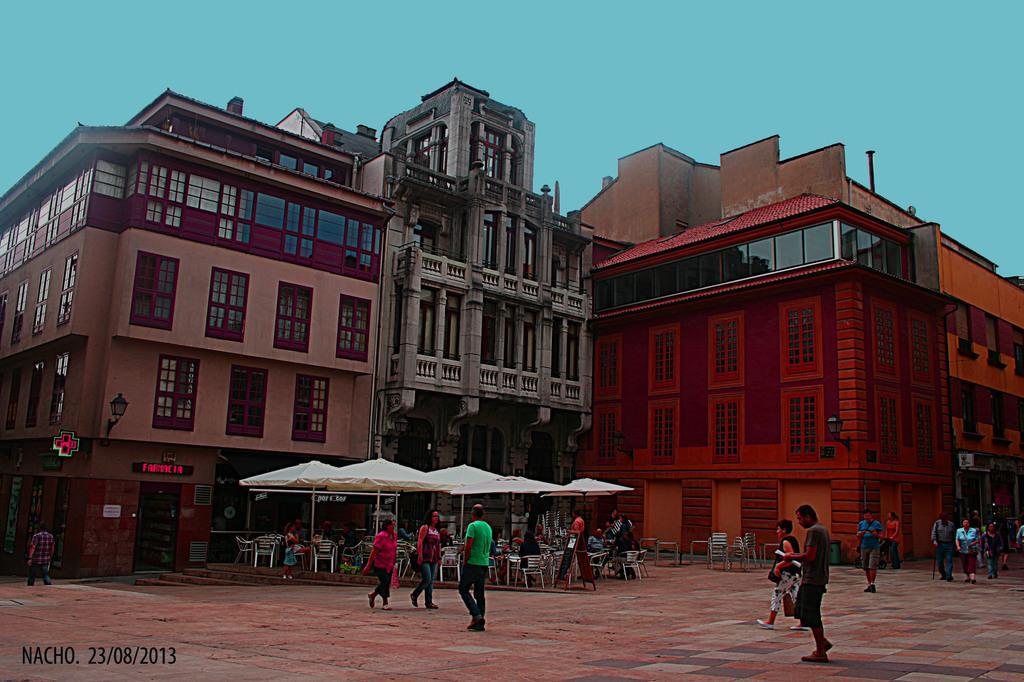Can you describe this image briefly? In this image, on the right side, we can see a group of people walking on the road. In the middle of the image, we can see three people are walking on the road. On the left side, we can see a man walking. In the background, we can see a group of people sitting on the chair under the umbrella. In the background, we can see a building, street light, display, pillars, glass window, doors. At the top, we can see a sky. 